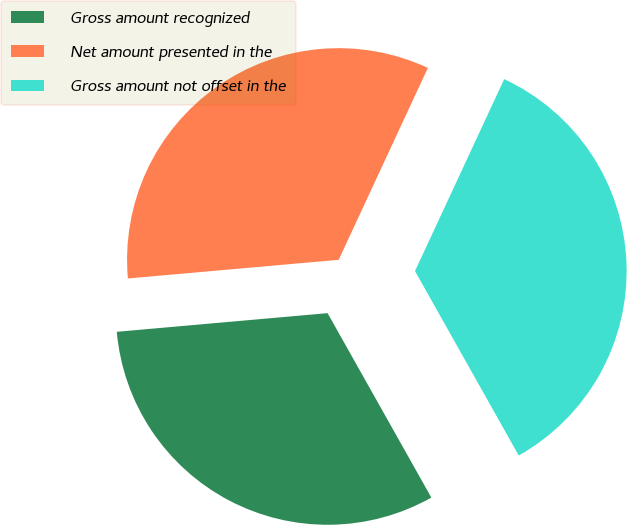Convert chart to OTSL. <chart><loc_0><loc_0><loc_500><loc_500><pie_chart><fcel>Gross amount recognized<fcel>Net amount presented in the<fcel>Gross amount not offset in the<nl><fcel>31.75%<fcel>33.33%<fcel>34.92%<nl></chart> 